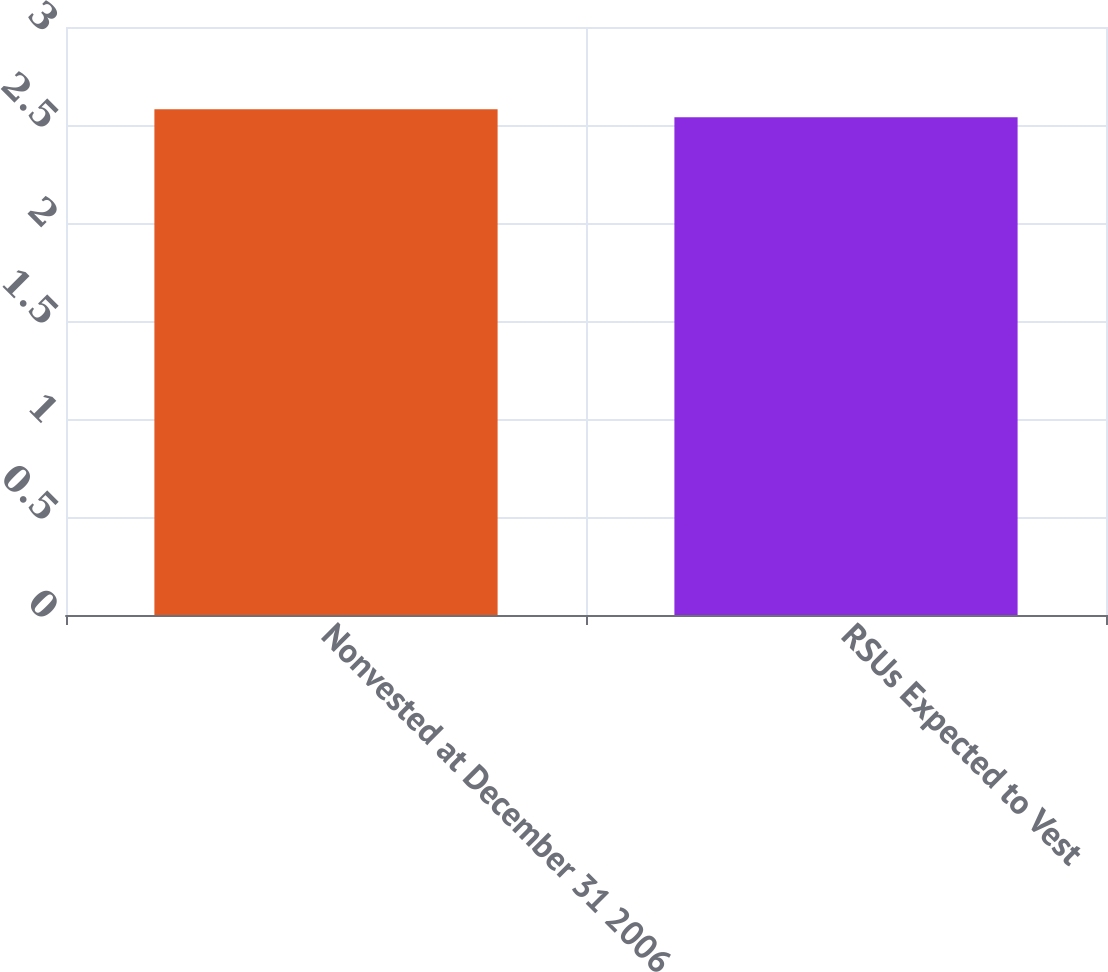Convert chart to OTSL. <chart><loc_0><loc_0><loc_500><loc_500><bar_chart><fcel>Nonvested at December 31 2006<fcel>RSUs Expected to Vest<nl><fcel>2.58<fcel>2.54<nl></chart> 